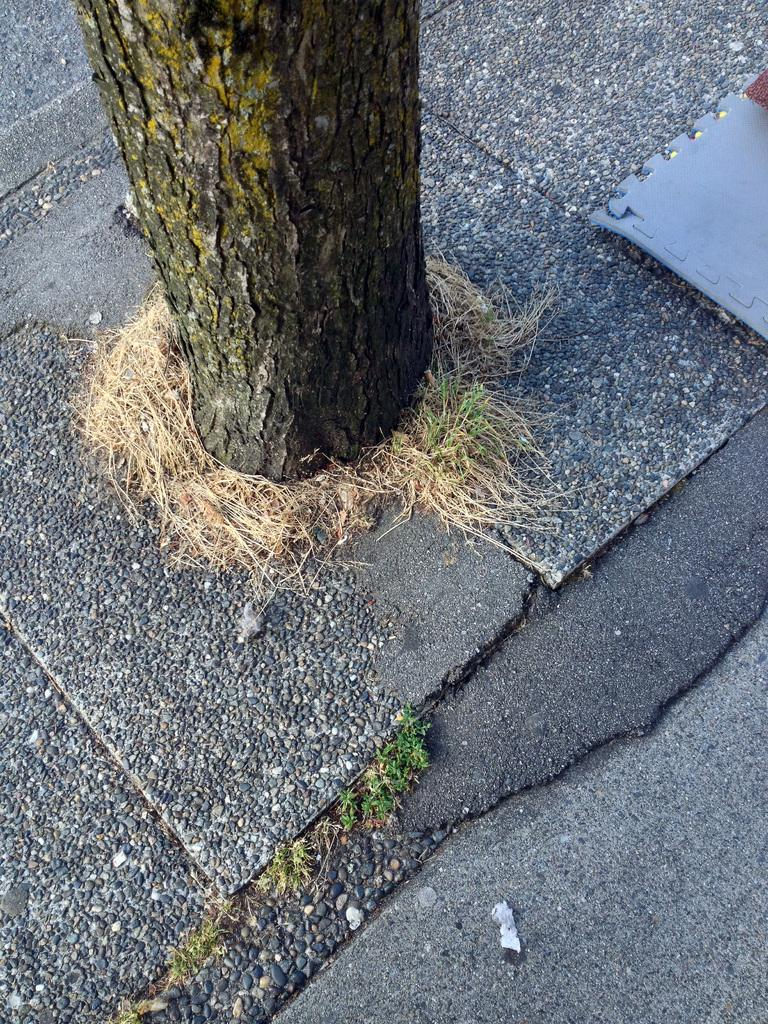What type of plant can be seen in the image? There is a tree in the image. What type of vegetation is present at the bottom of the image? There is grass at the bottom of the image. What hobbies are the people on the island in the image engaged in? There is no island or people present in the image; it only features a tree and grass. 